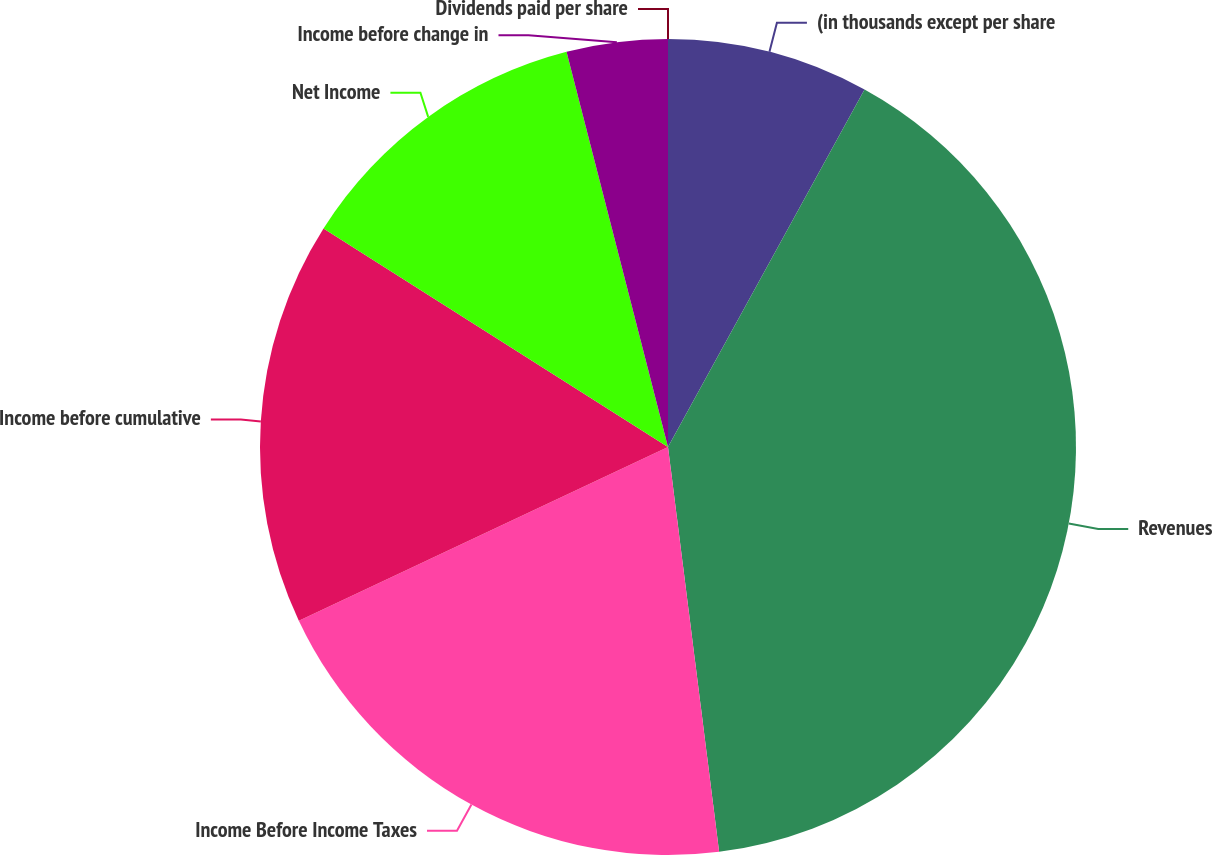Convert chart to OTSL. <chart><loc_0><loc_0><loc_500><loc_500><pie_chart><fcel>(in thousands except per share<fcel>Revenues<fcel>Income Before Income Taxes<fcel>Income before cumulative<fcel>Net Income<fcel>Income before change in<fcel>Dividends paid per share<nl><fcel>8.0%<fcel>40.0%<fcel>20.0%<fcel>16.0%<fcel>12.0%<fcel>4.0%<fcel>0.0%<nl></chart> 